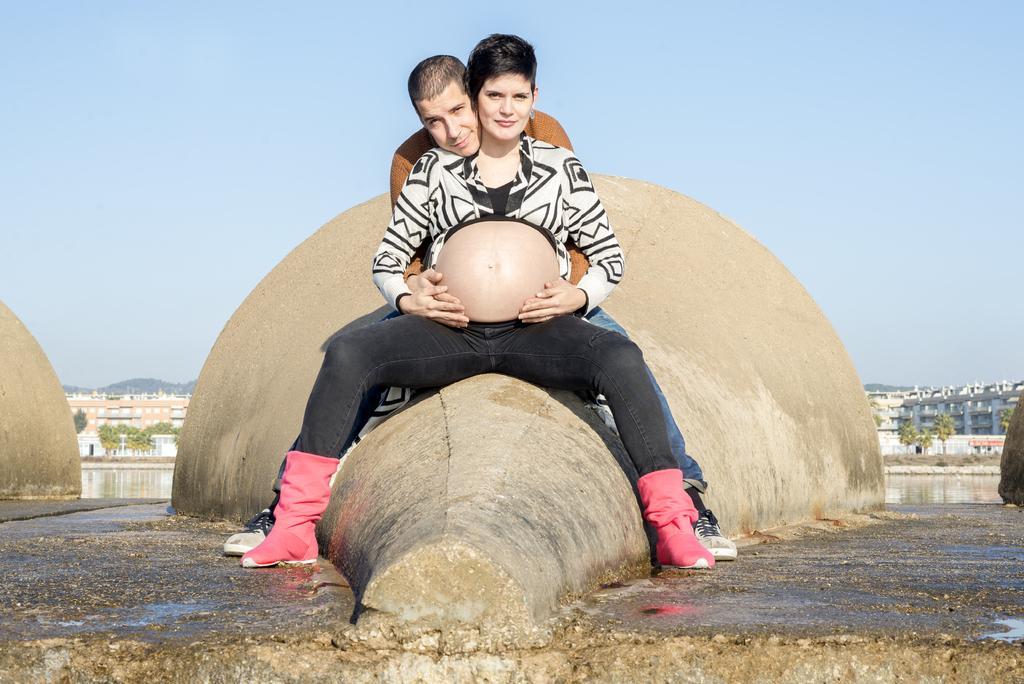Please provide a concise description of this image. A woman is sitting she wore a black color trouser. Behind him there is a man, at the top it's a sunny sky. 